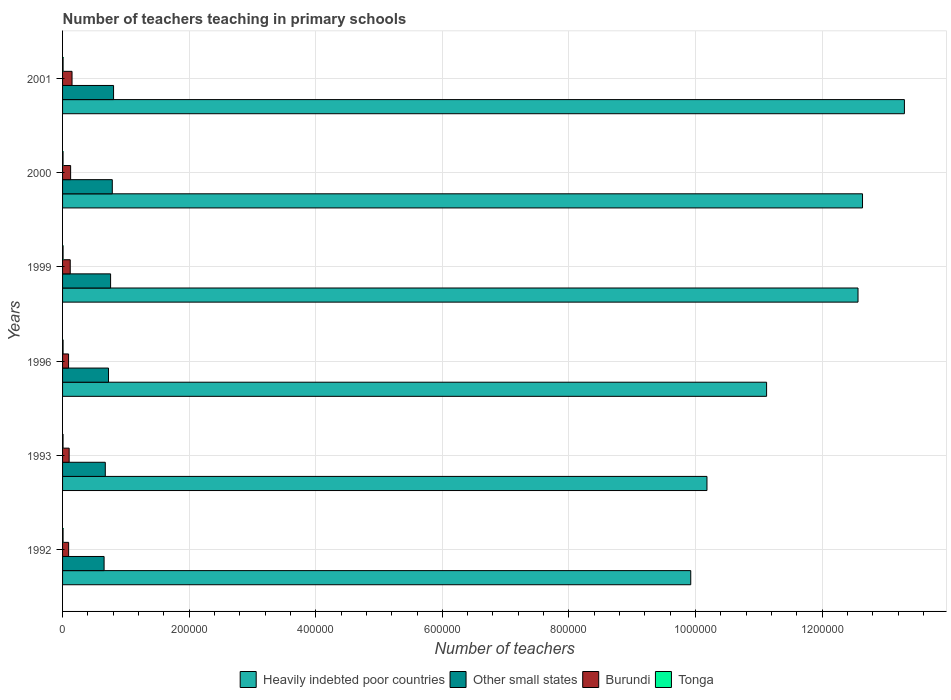How many different coloured bars are there?
Ensure brevity in your answer.  4. How many groups of bars are there?
Your answer should be very brief. 6. Are the number of bars on each tick of the Y-axis equal?
Provide a succinct answer. Yes. In how many cases, is the number of bars for a given year not equal to the number of legend labels?
Your answer should be compact. 0. What is the number of teachers teaching in primary schools in Tonga in 2000?
Provide a short and direct response. 754. Across all years, what is the maximum number of teachers teaching in primary schools in Burundi?
Your answer should be compact. 1.50e+04. Across all years, what is the minimum number of teachers teaching in primary schools in Tonga?
Give a very brief answer. 754. In which year was the number of teachers teaching in primary schools in Other small states minimum?
Offer a terse response. 1992. What is the total number of teachers teaching in primary schools in Tonga in the graph?
Your answer should be very brief. 4722. What is the difference between the number of teachers teaching in primary schools in Burundi in 1993 and that in 1996?
Your answer should be compact. 925. What is the difference between the number of teachers teaching in primary schools in Other small states in 1996 and the number of teachers teaching in primary schools in Tonga in 2001?
Offer a terse response. 7.18e+04. What is the average number of teachers teaching in primary schools in Heavily indebted poor countries per year?
Your answer should be very brief. 1.16e+06. In the year 1999, what is the difference between the number of teachers teaching in primary schools in Burundi and number of teachers teaching in primary schools in Heavily indebted poor countries?
Ensure brevity in your answer.  -1.24e+06. In how many years, is the number of teachers teaching in primary schools in Other small states greater than 1240000 ?
Ensure brevity in your answer.  0. What is the ratio of the number of teachers teaching in primary schools in Heavily indebted poor countries in 1996 to that in 1999?
Your response must be concise. 0.89. Is the number of teachers teaching in primary schools in Tonga in 1993 less than that in 1999?
Your answer should be compact. Yes. What is the difference between the highest and the second highest number of teachers teaching in primary schools in Burundi?
Provide a short and direct response. 2224. What is the difference between the highest and the lowest number of teachers teaching in primary schools in Heavily indebted poor countries?
Offer a terse response. 3.38e+05. In how many years, is the number of teachers teaching in primary schools in Other small states greater than the average number of teachers teaching in primary schools in Other small states taken over all years?
Provide a short and direct response. 3. What does the 1st bar from the top in 2001 represents?
Ensure brevity in your answer.  Tonga. What does the 2nd bar from the bottom in 1992 represents?
Provide a short and direct response. Other small states. Is it the case that in every year, the sum of the number of teachers teaching in primary schools in Heavily indebted poor countries and number of teachers teaching in primary schools in Tonga is greater than the number of teachers teaching in primary schools in Burundi?
Your answer should be very brief. Yes. Are all the bars in the graph horizontal?
Provide a succinct answer. Yes. How many years are there in the graph?
Your response must be concise. 6. What is the difference between two consecutive major ticks on the X-axis?
Make the answer very short. 2.00e+05. Are the values on the major ticks of X-axis written in scientific E-notation?
Make the answer very short. No. Does the graph contain grids?
Ensure brevity in your answer.  Yes. How many legend labels are there?
Provide a succinct answer. 4. How are the legend labels stacked?
Your answer should be compact. Horizontal. What is the title of the graph?
Give a very brief answer. Number of teachers teaching in primary schools. Does "Lesotho" appear as one of the legend labels in the graph?
Provide a succinct answer. No. What is the label or title of the X-axis?
Offer a terse response. Number of teachers. What is the Number of teachers of Heavily indebted poor countries in 1992?
Ensure brevity in your answer.  9.92e+05. What is the Number of teachers of Other small states in 1992?
Offer a terse response. 6.56e+04. What is the Number of teachers of Burundi in 1992?
Ensure brevity in your answer.  9582. What is the Number of teachers in Tonga in 1992?
Make the answer very short. 784. What is the Number of teachers in Heavily indebted poor countries in 1993?
Your answer should be very brief. 1.02e+06. What is the Number of teachers in Other small states in 1993?
Provide a succinct answer. 6.75e+04. What is the Number of teachers of Burundi in 1993?
Provide a short and direct response. 1.04e+04. What is the Number of teachers of Tonga in 1993?
Provide a short and direct response. 754. What is the Number of teachers of Heavily indebted poor countries in 1996?
Offer a terse response. 1.11e+06. What is the Number of teachers of Other small states in 1996?
Your answer should be compact. 7.26e+04. What is the Number of teachers in Burundi in 1996?
Keep it short and to the point. 9475. What is the Number of teachers in Tonga in 1996?
Offer a very short reply. 804. What is the Number of teachers in Heavily indebted poor countries in 1999?
Offer a terse response. 1.26e+06. What is the Number of teachers in Other small states in 1999?
Offer a terse response. 7.59e+04. What is the Number of teachers of Burundi in 1999?
Ensure brevity in your answer.  1.21e+04. What is the Number of teachers of Tonga in 1999?
Make the answer very short. 803. What is the Number of teachers of Heavily indebted poor countries in 2000?
Your response must be concise. 1.26e+06. What is the Number of teachers of Other small states in 2000?
Ensure brevity in your answer.  7.86e+04. What is the Number of teachers of Burundi in 2000?
Provide a short and direct response. 1.27e+04. What is the Number of teachers of Tonga in 2000?
Your answer should be very brief. 754. What is the Number of teachers in Heavily indebted poor countries in 2001?
Provide a succinct answer. 1.33e+06. What is the Number of teachers in Other small states in 2001?
Ensure brevity in your answer.  8.06e+04. What is the Number of teachers of Burundi in 2001?
Your response must be concise. 1.50e+04. What is the Number of teachers of Tonga in 2001?
Provide a succinct answer. 823. Across all years, what is the maximum Number of teachers of Heavily indebted poor countries?
Make the answer very short. 1.33e+06. Across all years, what is the maximum Number of teachers in Other small states?
Your answer should be compact. 8.06e+04. Across all years, what is the maximum Number of teachers in Burundi?
Offer a very short reply. 1.50e+04. Across all years, what is the maximum Number of teachers of Tonga?
Provide a succinct answer. 823. Across all years, what is the minimum Number of teachers of Heavily indebted poor countries?
Offer a terse response. 9.92e+05. Across all years, what is the minimum Number of teachers in Other small states?
Provide a short and direct response. 6.56e+04. Across all years, what is the minimum Number of teachers of Burundi?
Offer a very short reply. 9475. Across all years, what is the minimum Number of teachers of Tonga?
Make the answer very short. 754. What is the total Number of teachers in Heavily indebted poor countries in the graph?
Provide a short and direct response. 6.97e+06. What is the total Number of teachers of Other small states in the graph?
Your response must be concise. 4.41e+05. What is the total Number of teachers in Burundi in the graph?
Keep it short and to the point. 6.92e+04. What is the total Number of teachers in Tonga in the graph?
Provide a succinct answer. 4722. What is the difference between the Number of teachers of Heavily indebted poor countries in 1992 and that in 1993?
Ensure brevity in your answer.  -2.56e+04. What is the difference between the Number of teachers of Other small states in 1992 and that in 1993?
Make the answer very short. -1916.59. What is the difference between the Number of teachers in Burundi in 1992 and that in 1993?
Your answer should be compact. -818. What is the difference between the Number of teachers in Tonga in 1992 and that in 1993?
Provide a succinct answer. 30. What is the difference between the Number of teachers in Heavily indebted poor countries in 1992 and that in 1996?
Provide a short and direct response. -1.20e+05. What is the difference between the Number of teachers of Other small states in 1992 and that in 1996?
Your response must be concise. -6988.88. What is the difference between the Number of teachers in Burundi in 1992 and that in 1996?
Your answer should be compact. 107. What is the difference between the Number of teachers in Heavily indebted poor countries in 1992 and that in 1999?
Provide a succinct answer. -2.64e+05. What is the difference between the Number of teachers in Other small states in 1992 and that in 1999?
Offer a very short reply. -1.03e+04. What is the difference between the Number of teachers of Burundi in 1992 and that in 1999?
Offer a terse response. -2525. What is the difference between the Number of teachers in Heavily indebted poor countries in 1992 and that in 2000?
Offer a very short reply. -2.71e+05. What is the difference between the Number of teachers in Other small states in 1992 and that in 2000?
Provide a succinct answer. -1.30e+04. What is the difference between the Number of teachers in Burundi in 1992 and that in 2000?
Offer a terse response. -3149. What is the difference between the Number of teachers in Heavily indebted poor countries in 1992 and that in 2001?
Make the answer very short. -3.38e+05. What is the difference between the Number of teachers of Other small states in 1992 and that in 2001?
Offer a terse response. -1.50e+04. What is the difference between the Number of teachers of Burundi in 1992 and that in 2001?
Keep it short and to the point. -5373. What is the difference between the Number of teachers of Tonga in 1992 and that in 2001?
Offer a very short reply. -39. What is the difference between the Number of teachers of Heavily indebted poor countries in 1993 and that in 1996?
Keep it short and to the point. -9.42e+04. What is the difference between the Number of teachers in Other small states in 1993 and that in 1996?
Offer a terse response. -5072.28. What is the difference between the Number of teachers of Burundi in 1993 and that in 1996?
Ensure brevity in your answer.  925. What is the difference between the Number of teachers of Tonga in 1993 and that in 1996?
Make the answer very short. -50. What is the difference between the Number of teachers of Heavily indebted poor countries in 1993 and that in 1999?
Make the answer very short. -2.39e+05. What is the difference between the Number of teachers in Other small states in 1993 and that in 1999?
Offer a terse response. -8356.26. What is the difference between the Number of teachers in Burundi in 1993 and that in 1999?
Your response must be concise. -1707. What is the difference between the Number of teachers of Tonga in 1993 and that in 1999?
Your answer should be very brief. -49. What is the difference between the Number of teachers of Heavily indebted poor countries in 1993 and that in 2000?
Keep it short and to the point. -2.46e+05. What is the difference between the Number of teachers of Other small states in 1993 and that in 2000?
Your answer should be very brief. -1.11e+04. What is the difference between the Number of teachers of Burundi in 1993 and that in 2000?
Your answer should be very brief. -2331. What is the difference between the Number of teachers in Tonga in 1993 and that in 2000?
Provide a short and direct response. 0. What is the difference between the Number of teachers of Heavily indebted poor countries in 1993 and that in 2001?
Your answer should be compact. -3.12e+05. What is the difference between the Number of teachers in Other small states in 1993 and that in 2001?
Ensure brevity in your answer.  -1.30e+04. What is the difference between the Number of teachers of Burundi in 1993 and that in 2001?
Make the answer very short. -4555. What is the difference between the Number of teachers in Tonga in 1993 and that in 2001?
Your answer should be compact. -69. What is the difference between the Number of teachers in Heavily indebted poor countries in 1996 and that in 1999?
Make the answer very short. -1.44e+05. What is the difference between the Number of teachers in Other small states in 1996 and that in 1999?
Your response must be concise. -3283.98. What is the difference between the Number of teachers of Burundi in 1996 and that in 1999?
Offer a terse response. -2632. What is the difference between the Number of teachers of Heavily indebted poor countries in 1996 and that in 2000?
Offer a terse response. -1.52e+05. What is the difference between the Number of teachers in Other small states in 1996 and that in 2000?
Your answer should be compact. -5991.24. What is the difference between the Number of teachers of Burundi in 1996 and that in 2000?
Provide a short and direct response. -3256. What is the difference between the Number of teachers of Heavily indebted poor countries in 1996 and that in 2001?
Your answer should be very brief. -2.18e+05. What is the difference between the Number of teachers in Other small states in 1996 and that in 2001?
Give a very brief answer. -7967.1. What is the difference between the Number of teachers of Burundi in 1996 and that in 2001?
Your answer should be compact. -5480. What is the difference between the Number of teachers of Tonga in 1996 and that in 2001?
Offer a very short reply. -19. What is the difference between the Number of teachers of Heavily indebted poor countries in 1999 and that in 2000?
Offer a terse response. -7112.5. What is the difference between the Number of teachers in Other small states in 1999 and that in 2000?
Your answer should be very brief. -2707.27. What is the difference between the Number of teachers in Burundi in 1999 and that in 2000?
Provide a short and direct response. -624. What is the difference between the Number of teachers of Heavily indebted poor countries in 1999 and that in 2001?
Ensure brevity in your answer.  -7.33e+04. What is the difference between the Number of teachers of Other small states in 1999 and that in 2001?
Give a very brief answer. -4683.12. What is the difference between the Number of teachers of Burundi in 1999 and that in 2001?
Give a very brief answer. -2848. What is the difference between the Number of teachers of Heavily indebted poor countries in 2000 and that in 2001?
Give a very brief answer. -6.62e+04. What is the difference between the Number of teachers in Other small states in 2000 and that in 2001?
Keep it short and to the point. -1975.86. What is the difference between the Number of teachers of Burundi in 2000 and that in 2001?
Make the answer very short. -2224. What is the difference between the Number of teachers in Tonga in 2000 and that in 2001?
Your answer should be very brief. -69. What is the difference between the Number of teachers in Heavily indebted poor countries in 1992 and the Number of teachers in Other small states in 1993?
Keep it short and to the point. 9.25e+05. What is the difference between the Number of teachers of Heavily indebted poor countries in 1992 and the Number of teachers of Burundi in 1993?
Ensure brevity in your answer.  9.82e+05. What is the difference between the Number of teachers of Heavily indebted poor countries in 1992 and the Number of teachers of Tonga in 1993?
Provide a succinct answer. 9.92e+05. What is the difference between the Number of teachers of Other small states in 1992 and the Number of teachers of Burundi in 1993?
Ensure brevity in your answer.  5.52e+04. What is the difference between the Number of teachers in Other small states in 1992 and the Number of teachers in Tonga in 1993?
Offer a very short reply. 6.48e+04. What is the difference between the Number of teachers in Burundi in 1992 and the Number of teachers in Tonga in 1993?
Your response must be concise. 8828. What is the difference between the Number of teachers of Heavily indebted poor countries in 1992 and the Number of teachers of Other small states in 1996?
Provide a short and direct response. 9.20e+05. What is the difference between the Number of teachers in Heavily indebted poor countries in 1992 and the Number of teachers in Burundi in 1996?
Make the answer very short. 9.83e+05. What is the difference between the Number of teachers in Heavily indebted poor countries in 1992 and the Number of teachers in Tonga in 1996?
Make the answer very short. 9.92e+05. What is the difference between the Number of teachers in Other small states in 1992 and the Number of teachers in Burundi in 1996?
Make the answer very short. 5.61e+04. What is the difference between the Number of teachers in Other small states in 1992 and the Number of teachers in Tonga in 1996?
Provide a short and direct response. 6.48e+04. What is the difference between the Number of teachers in Burundi in 1992 and the Number of teachers in Tonga in 1996?
Give a very brief answer. 8778. What is the difference between the Number of teachers of Heavily indebted poor countries in 1992 and the Number of teachers of Other small states in 1999?
Give a very brief answer. 9.17e+05. What is the difference between the Number of teachers in Heavily indebted poor countries in 1992 and the Number of teachers in Burundi in 1999?
Provide a short and direct response. 9.80e+05. What is the difference between the Number of teachers in Heavily indebted poor countries in 1992 and the Number of teachers in Tonga in 1999?
Your answer should be very brief. 9.92e+05. What is the difference between the Number of teachers of Other small states in 1992 and the Number of teachers of Burundi in 1999?
Provide a short and direct response. 5.35e+04. What is the difference between the Number of teachers of Other small states in 1992 and the Number of teachers of Tonga in 1999?
Provide a short and direct response. 6.48e+04. What is the difference between the Number of teachers of Burundi in 1992 and the Number of teachers of Tonga in 1999?
Offer a terse response. 8779. What is the difference between the Number of teachers in Heavily indebted poor countries in 1992 and the Number of teachers in Other small states in 2000?
Make the answer very short. 9.14e+05. What is the difference between the Number of teachers of Heavily indebted poor countries in 1992 and the Number of teachers of Burundi in 2000?
Make the answer very short. 9.80e+05. What is the difference between the Number of teachers in Heavily indebted poor countries in 1992 and the Number of teachers in Tonga in 2000?
Your answer should be very brief. 9.92e+05. What is the difference between the Number of teachers of Other small states in 1992 and the Number of teachers of Burundi in 2000?
Make the answer very short. 5.29e+04. What is the difference between the Number of teachers in Other small states in 1992 and the Number of teachers in Tonga in 2000?
Provide a short and direct response. 6.48e+04. What is the difference between the Number of teachers in Burundi in 1992 and the Number of teachers in Tonga in 2000?
Your answer should be compact. 8828. What is the difference between the Number of teachers of Heavily indebted poor countries in 1992 and the Number of teachers of Other small states in 2001?
Make the answer very short. 9.12e+05. What is the difference between the Number of teachers of Heavily indebted poor countries in 1992 and the Number of teachers of Burundi in 2001?
Offer a very short reply. 9.78e+05. What is the difference between the Number of teachers of Heavily indebted poor countries in 1992 and the Number of teachers of Tonga in 2001?
Your response must be concise. 9.92e+05. What is the difference between the Number of teachers in Other small states in 1992 and the Number of teachers in Burundi in 2001?
Make the answer very short. 5.06e+04. What is the difference between the Number of teachers of Other small states in 1992 and the Number of teachers of Tonga in 2001?
Ensure brevity in your answer.  6.48e+04. What is the difference between the Number of teachers of Burundi in 1992 and the Number of teachers of Tonga in 2001?
Give a very brief answer. 8759. What is the difference between the Number of teachers of Heavily indebted poor countries in 1993 and the Number of teachers of Other small states in 1996?
Offer a very short reply. 9.46e+05. What is the difference between the Number of teachers in Heavily indebted poor countries in 1993 and the Number of teachers in Burundi in 1996?
Ensure brevity in your answer.  1.01e+06. What is the difference between the Number of teachers of Heavily indebted poor countries in 1993 and the Number of teachers of Tonga in 1996?
Your answer should be very brief. 1.02e+06. What is the difference between the Number of teachers in Other small states in 1993 and the Number of teachers in Burundi in 1996?
Give a very brief answer. 5.80e+04. What is the difference between the Number of teachers in Other small states in 1993 and the Number of teachers in Tonga in 1996?
Your answer should be very brief. 6.67e+04. What is the difference between the Number of teachers of Burundi in 1993 and the Number of teachers of Tonga in 1996?
Offer a very short reply. 9596. What is the difference between the Number of teachers of Heavily indebted poor countries in 1993 and the Number of teachers of Other small states in 1999?
Keep it short and to the point. 9.42e+05. What is the difference between the Number of teachers of Heavily indebted poor countries in 1993 and the Number of teachers of Burundi in 1999?
Give a very brief answer. 1.01e+06. What is the difference between the Number of teachers in Heavily indebted poor countries in 1993 and the Number of teachers in Tonga in 1999?
Ensure brevity in your answer.  1.02e+06. What is the difference between the Number of teachers in Other small states in 1993 and the Number of teachers in Burundi in 1999?
Make the answer very short. 5.54e+04. What is the difference between the Number of teachers in Other small states in 1993 and the Number of teachers in Tonga in 1999?
Provide a short and direct response. 6.67e+04. What is the difference between the Number of teachers of Burundi in 1993 and the Number of teachers of Tonga in 1999?
Your answer should be very brief. 9597. What is the difference between the Number of teachers in Heavily indebted poor countries in 1993 and the Number of teachers in Other small states in 2000?
Your answer should be very brief. 9.40e+05. What is the difference between the Number of teachers of Heavily indebted poor countries in 1993 and the Number of teachers of Burundi in 2000?
Give a very brief answer. 1.01e+06. What is the difference between the Number of teachers of Heavily indebted poor countries in 1993 and the Number of teachers of Tonga in 2000?
Make the answer very short. 1.02e+06. What is the difference between the Number of teachers in Other small states in 1993 and the Number of teachers in Burundi in 2000?
Make the answer very short. 5.48e+04. What is the difference between the Number of teachers of Other small states in 1993 and the Number of teachers of Tonga in 2000?
Offer a terse response. 6.68e+04. What is the difference between the Number of teachers in Burundi in 1993 and the Number of teachers in Tonga in 2000?
Keep it short and to the point. 9646. What is the difference between the Number of teachers in Heavily indebted poor countries in 1993 and the Number of teachers in Other small states in 2001?
Your answer should be compact. 9.38e+05. What is the difference between the Number of teachers of Heavily indebted poor countries in 1993 and the Number of teachers of Burundi in 2001?
Your answer should be very brief. 1.00e+06. What is the difference between the Number of teachers of Heavily indebted poor countries in 1993 and the Number of teachers of Tonga in 2001?
Give a very brief answer. 1.02e+06. What is the difference between the Number of teachers of Other small states in 1993 and the Number of teachers of Burundi in 2001?
Your answer should be very brief. 5.26e+04. What is the difference between the Number of teachers in Other small states in 1993 and the Number of teachers in Tonga in 2001?
Your answer should be very brief. 6.67e+04. What is the difference between the Number of teachers in Burundi in 1993 and the Number of teachers in Tonga in 2001?
Your response must be concise. 9577. What is the difference between the Number of teachers in Heavily indebted poor countries in 1996 and the Number of teachers in Other small states in 1999?
Provide a succinct answer. 1.04e+06. What is the difference between the Number of teachers in Heavily indebted poor countries in 1996 and the Number of teachers in Burundi in 1999?
Offer a very short reply. 1.10e+06. What is the difference between the Number of teachers of Heavily indebted poor countries in 1996 and the Number of teachers of Tonga in 1999?
Offer a terse response. 1.11e+06. What is the difference between the Number of teachers in Other small states in 1996 and the Number of teachers in Burundi in 1999?
Provide a short and direct response. 6.05e+04. What is the difference between the Number of teachers of Other small states in 1996 and the Number of teachers of Tonga in 1999?
Ensure brevity in your answer.  7.18e+04. What is the difference between the Number of teachers of Burundi in 1996 and the Number of teachers of Tonga in 1999?
Your response must be concise. 8672. What is the difference between the Number of teachers of Heavily indebted poor countries in 1996 and the Number of teachers of Other small states in 2000?
Make the answer very short. 1.03e+06. What is the difference between the Number of teachers of Heavily indebted poor countries in 1996 and the Number of teachers of Burundi in 2000?
Your answer should be very brief. 1.10e+06. What is the difference between the Number of teachers in Heavily indebted poor countries in 1996 and the Number of teachers in Tonga in 2000?
Provide a succinct answer. 1.11e+06. What is the difference between the Number of teachers in Other small states in 1996 and the Number of teachers in Burundi in 2000?
Your answer should be compact. 5.99e+04. What is the difference between the Number of teachers of Other small states in 1996 and the Number of teachers of Tonga in 2000?
Make the answer very short. 7.18e+04. What is the difference between the Number of teachers in Burundi in 1996 and the Number of teachers in Tonga in 2000?
Keep it short and to the point. 8721. What is the difference between the Number of teachers in Heavily indebted poor countries in 1996 and the Number of teachers in Other small states in 2001?
Your answer should be compact. 1.03e+06. What is the difference between the Number of teachers of Heavily indebted poor countries in 1996 and the Number of teachers of Burundi in 2001?
Provide a succinct answer. 1.10e+06. What is the difference between the Number of teachers in Heavily indebted poor countries in 1996 and the Number of teachers in Tonga in 2001?
Your answer should be very brief. 1.11e+06. What is the difference between the Number of teachers in Other small states in 1996 and the Number of teachers in Burundi in 2001?
Give a very brief answer. 5.76e+04. What is the difference between the Number of teachers in Other small states in 1996 and the Number of teachers in Tonga in 2001?
Ensure brevity in your answer.  7.18e+04. What is the difference between the Number of teachers in Burundi in 1996 and the Number of teachers in Tonga in 2001?
Provide a short and direct response. 8652. What is the difference between the Number of teachers of Heavily indebted poor countries in 1999 and the Number of teachers of Other small states in 2000?
Make the answer very short. 1.18e+06. What is the difference between the Number of teachers in Heavily indebted poor countries in 1999 and the Number of teachers in Burundi in 2000?
Your answer should be very brief. 1.24e+06. What is the difference between the Number of teachers of Heavily indebted poor countries in 1999 and the Number of teachers of Tonga in 2000?
Provide a short and direct response. 1.26e+06. What is the difference between the Number of teachers of Other small states in 1999 and the Number of teachers of Burundi in 2000?
Offer a terse response. 6.31e+04. What is the difference between the Number of teachers in Other small states in 1999 and the Number of teachers in Tonga in 2000?
Keep it short and to the point. 7.51e+04. What is the difference between the Number of teachers of Burundi in 1999 and the Number of teachers of Tonga in 2000?
Your response must be concise. 1.14e+04. What is the difference between the Number of teachers in Heavily indebted poor countries in 1999 and the Number of teachers in Other small states in 2001?
Provide a succinct answer. 1.18e+06. What is the difference between the Number of teachers in Heavily indebted poor countries in 1999 and the Number of teachers in Burundi in 2001?
Make the answer very short. 1.24e+06. What is the difference between the Number of teachers of Heavily indebted poor countries in 1999 and the Number of teachers of Tonga in 2001?
Offer a terse response. 1.26e+06. What is the difference between the Number of teachers in Other small states in 1999 and the Number of teachers in Burundi in 2001?
Offer a terse response. 6.09e+04. What is the difference between the Number of teachers of Other small states in 1999 and the Number of teachers of Tonga in 2001?
Give a very brief answer. 7.51e+04. What is the difference between the Number of teachers in Burundi in 1999 and the Number of teachers in Tonga in 2001?
Provide a succinct answer. 1.13e+04. What is the difference between the Number of teachers in Heavily indebted poor countries in 2000 and the Number of teachers in Other small states in 2001?
Give a very brief answer. 1.18e+06. What is the difference between the Number of teachers in Heavily indebted poor countries in 2000 and the Number of teachers in Burundi in 2001?
Your response must be concise. 1.25e+06. What is the difference between the Number of teachers of Heavily indebted poor countries in 2000 and the Number of teachers of Tonga in 2001?
Offer a terse response. 1.26e+06. What is the difference between the Number of teachers in Other small states in 2000 and the Number of teachers in Burundi in 2001?
Provide a short and direct response. 6.36e+04. What is the difference between the Number of teachers in Other small states in 2000 and the Number of teachers in Tonga in 2001?
Give a very brief answer. 7.78e+04. What is the difference between the Number of teachers in Burundi in 2000 and the Number of teachers in Tonga in 2001?
Offer a terse response. 1.19e+04. What is the average Number of teachers in Heavily indebted poor countries per year?
Provide a succinct answer. 1.16e+06. What is the average Number of teachers in Other small states per year?
Ensure brevity in your answer.  7.35e+04. What is the average Number of teachers in Burundi per year?
Keep it short and to the point. 1.15e+04. What is the average Number of teachers of Tonga per year?
Your answer should be compact. 787. In the year 1992, what is the difference between the Number of teachers of Heavily indebted poor countries and Number of teachers of Other small states?
Offer a very short reply. 9.27e+05. In the year 1992, what is the difference between the Number of teachers of Heavily indebted poor countries and Number of teachers of Burundi?
Your answer should be very brief. 9.83e+05. In the year 1992, what is the difference between the Number of teachers in Heavily indebted poor countries and Number of teachers in Tonga?
Offer a very short reply. 9.92e+05. In the year 1992, what is the difference between the Number of teachers in Other small states and Number of teachers in Burundi?
Make the answer very short. 5.60e+04. In the year 1992, what is the difference between the Number of teachers in Other small states and Number of teachers in Tonga?
Offer a terse response. 6.48e+04. In the year 1992, what is the difference between the Number of teachers of Burundi and Number of teachers of Tonga?
Your answer should be very brief. 8798. In the year 1993, what is the difference between the Number of teachers in Heavily indebted poor countries and Number of teachers in Other small states?
Keep it short and to the point. 9.51e+05. In the year 1993, what is the difference between the Number of teachers of Heavily indebted poor countries and Number of teachers of Burundi?
Your response must be concise. 1.01e+06. In the year 1993, what is the difference between the Number of teachers of Heavily indebted poor countries and Number of teachers of Tonga?
Give a very brief answer. 1.02e+06. In the year 1993, what is the difference between the Number of teachers of Other small states and Number of teachers of Burundi?
Ensure brevity in your answer.  5.71e+04. In the year 1993, what is the difference between the Number of teachers of Other small states and Number of teachers of Tonga?
Provide a short and direct response. 6.68e+04. In the year 1993, what is the difference between the Number of teachers in Burundi and Number of teachers in Tonga?
Make the answer very short. 9646. In the year 1996, what is the difference between the Number of teachers of Heavily indebted poor countries and Number of teachers of Other small states?
Give a very brief answer. 1.04e+06. In the year 1996, what is the difference between the Number of teachers in Heavily indebted poor countries and Number of teachers in Burundi?
Give a very brief answer. 1.10e+06. In the year 1996, what is the difference between the Number of teachers of Heavily indebted poor countries and Number of teachers of Tonga?
Your answer should be compact. 1.11e+06. In the year 1996, what is the difference between the Number of teachers of Other small states and Number of teachers of Burundi?
Your answer should be very brief. 6.31e+04. In the year 1996, what is the difference between the Number of teachers in Other small states and Number of teachers in Tonga?
Provide a short and direct response. 7.18e+04. In the year 1996, what is the difference between the Number of teachers of Burundi and Number of teachers of Tonga?
Keep it short and to the point. 8671. In the year 1999, what is the difference between the Number of teachers of Heavily indebted poor countries and Number of teachers of Other small states?
Your answer should be very brief. 1.18e+06. In the year 1999, what is the difference between the Number of teachers of Heavily indebted poor countries and Number of teachers of Burundi?
Make the answer very short. 1.24e+06. In the year 1999, what is the difference between the Number of teachers in Heavily indebted poor countries and Number of teachers in Tonga?
Your answer should be very brief. 1.26e+06. In the year 1999, what is the difference between the Number of teachers of Other small states and Number of teachers of Burundi?
Offer a terse response. 6.38e+04. In the year 1999, what is the difference between the Number of teachers of Other small states and Number of teachers of Tonga?
Keep it short and to the point. 7.51e+04. In the year 1999, what is the difference between the Number of teachers in Burundi and Number of teachers in Tonga?
Make the answer very short. 1.13e+04. In the year 2000, what is the difference between the Number of teachers in Heavily indebted poor countries and Number of teachers in Other small states?
Your answer should be compact. 1.19e+06. In the year 2000, what is the difference between the Number of teachers of Heavily indebted poor countries and Number of teachers of Burundi?
Your response must be concise. 1.25e+06. In the year 2000, what is the difference between the Number of teachers in Heavily indebted poor countries and Number of teachers in Tonga?
Provide a short and direct response. 1.26e+06. In the year 2000, what is the difference between the Number of teachers of Other small states and Number of teachers of Burundi?
Your answer should be very brief. 6.59e+04. In the year 2000, what is the difference between the Number of teachers in Other small states and Number of teachers in Tonga?
Make the answer very short. 7.78e+04. In the year 2000, what is the difference between the Number of teachers of Burundi and Number of teachers of Tonga?
Your answer should be compact. 1.20e+04. In the year 2001, what is the difference between the Number of teachers in Heavily indebted poor countries and Number of teachers in Other small states?
Offer a terse response. 1.25e+06. In the year 2001, what is the difference between the Number of teachers of Heavily indebted poor countries and Number of teachers of Burundi?
Provide a succinct answer. 1.32e+06. In the year 2001, what is the difference between the Number of teachers in Heavily indebted poor countries and Number of teachers in Tonga?
Keep it short and to the point. 1.33e+06. In the year 2001, what is the difference between the Number of teachers in Other small states and Number of teachers in Burundi?
Make the answer very short. 6.56e+04. In the year 2001, what is the difference between the Number of teachers of Other small states and Number of teachers of Tonga?
Your response must be concise. 7.97e+04. In the year 2001, what is the difference between the Number of teachers of Burundi and Number of teachers of Tonga?
Offer a very short reply. 1.41e+04. What is the ratio of the Number of teachers in Heavily indebted poor countries in 1992 to that in 1993?
Provide a succinct answer. 0.97. What is the ratio of the Number of teachers in Other small states in 1992 to that in 1993?
Offer a very short reply. 0.97. What is the ratio of the Number of teachers of Burundi in 1992 to that in 1993?
Your response must be concise. 0.92. What is the ratio of the Number of teachers in Tonga in 1992 to that in 1993?
Keep it short and to the point. 1.04. What is the ratio of the Number of teachers of Heavily indebted poor countries in 1992 to that in 1996?
Offer a very short reply. 0.89. What is the ratio of the Number of teachers in Other small states in 1992 to that in 1996?
Give a very brief answer. 0.9. What is the ratio of the Number of teachers in Burundi in 1992 to that in 1996?
Provide a short and direct response. 1.01. What is the ratio of the Number of teachers in Tonga in 1992 to that in 1996?
Offer a very short reply. 0.98. What is the ratio of the Number of teachers of Heavily indebted poor countries in 1992 to that in 1999?
Your answer should be compact. 0.79. What is the ratio of the Number of teachers of Other small states in 1992 to that in 1999?
Make the answer very short. 0.86. What is the ratio of the Number of teachers in Burundi in 1992 to that in 1999?
Provide a short and direct response. 0.79. What is the ratio of the Number of teachers in Tonga in 1992 to that in 1999?
Keep it short and to the point. 0.98. What is the ratio of the Number of teachers in Heavily indebted poor countries in 1992 to that in 2000?
Keep it short and to the point. 0.79. What is the ratio of the Number of teachers of Other small states in 1992 to that in 2000?
Offer a terse response. 0.83. What is the ratio of the Number of teachers in Burundi in 1992 to that in 2000?
Your response must be concise. 0.75. What is the ratio of the Number of teachers in Tonga in 1992 to that in 2000?
Your response must be concise. 1.04. What is the ratio of the Number of teachers in Heavily indebted poor countries in 1992 to that in 2001?
Your response must be concise. 0.75. What is the ratio of the Number of teachers in Other small states in 1992 to that in 2001?
Offer a very short reply. 0.81. What is the ratio of the Number of teachers in Burundi in 1992 to that in 2001?
Ensure brevity in your answer.  0.64. What is the ratio of the Number of teachers of Tonga in 1992 to that in 2001?
Your answer should be very brief. 0.95. What is the ratio of the Number of teachers of Heavily indebted poor countries in 1993 to that in 1996?
Make the answer very short. 0.92. What is the ratio of the Number of teachers in Other small states in 1993 to that in 1996?
Give a very brief answer. 0.93. What is the ratio of the Number of teachers of Burundi in 1993 to that in 1996?
Your answer should be compact. 1.1. What is the ratio of the Number of teachers in Tonga in 1993 to that in 1996?
Provide a succinct answer. 0.94. What is the ratio of the Number of teachers of Heavily indebted poor countries in 1993 to that in 1999?
Keep it short and to the point. 0.81. What is the ratio of the Number of teachers in Other small states in 1993 to that in 1999?
Offer a very short reply. 0.89. What is the ratio of the Number of teachers of Burundi in 1993 to that in 1999?
Make the answer very short. 0.86. What is the ratio of the Number of teachers of Tonga in 1993 to that in 1999?
Provide a succinct answer. 0.94. What is the ratio of the Number of teachers of Heavily indebted poor countries in 1993 to that in 2000?
Your answer should be very brief. 0.81. What is the ratio of the Number of teachers in Other small states in 1993 to that in 2000?
Provide a succinct answer. 0.86. What is the ratio of the Number of teachers in Burundi in 1993 to that in 2000?
Your response must be concise. 0.82. What is the ratio of the Number of teachers in Tonga in 1993 to that in 2000?
Offer a very short reply. 1. What is the ratio of the Number of teachers in Heavily indebted poor countries in 1993 to that in 2001?
Your answer should be very brief. 0.77. What is the ratio of the Number of teachers in Other small states in 1993 to that in 2001?
Your answer should be very brief. 0.84. What is the ratio of the Number of teachers in Burundi in 1993 to that in 2001?
Offer a terse response. 0.7. What is the ratio of the Number of teachers of Tonga in 1993 to that in 2001?
Keep it short and to the point. 0.92. What is the ratio of the Number of teachers of Heavily indebted poor countries in 1996 to that in 1999?
Your answer should be very brief. 0.89. What is the ratio of the Number of teachers of Other small states in 1996 to that in 1999?
Provide a succinct answer. 0.96. What is the ratio of the Number of teachers in Burundi in 1996 to that in 1999?
Make the answer very short. 0.78. What is the ratio of the Number of teachers in Tonga in 1996 to that in 1999?
Your answer should be very brief. 1. What is the ratio of the Number of teachers of Heavily indebted poor countries in 1996 to that in 2000?
Your answer should be very brief. 0.88. What is the ratio of the Number of teachers of Other small states in 1996 to that in 2000?
Offer a very short reply. 0.92. What is the ratio of the Number of teachers of Burundi in 1996 to that in 2000?
Make the answer very short. 0.74. What is the ratio of the Number of teachers of Tonga in 1996 to that in 2000?
Your response must be concise. 1.07. What is the ratio of the Number of teachers of Heavily indebted poor countries in 1996 to that in 2001?
Offer a terse response. 0.84. What is the ratio of the Number of teachers in Other small states in 1996 to that in 2001?
Your answer should be very brief. 0.9. What is the ratio of the Number of teachers of Burundi in 1996 to that in 2001?
Make the answer very short. 0.63. What is the ratio of the Number of teachers of Tonga in 1996 to that in 2001?
Ensure brevity in your answer.  0.98. What is the ratio of the Number of teachers in Other small states in 1999 to that in 2000?
Ensure brevity in your answer.  0.97. What is the ratio of the Number of teachers of Burundi in 1999 to that in 2000?
Your answer should be very brief. 0.95. What is the ratio of the Number of teachers in Tonga in 1999 to that in 2000?
Make the answer very short. 1.06. What is the ratio of the Number of teachers of Heavily indebted poor countries in 1999 to that in 2001?
Your answer should be compact. 0.94. What is the ratio of the Number of teachers in Other small states in 1999 to that in 2001?
Make the answer very short. 0.94. What is the ratio of the Number of teachers in Burundi in 1999 to that in 2001?
Give a very brief answer. 0.81. What is the ratio of the Number of teachers in Tonga in 1999 to that in 2001?
Give a very brief answer. 0.98. What is the ratio of the Number of teachers in Heavily indebted poor countries in 2000 to that in 2001?
Offer a very short reply. 0.95. What is the ratio of the Number of teachers of Other small states in 2000 to that in 2001?
Offer a terse response. 0.98. What is the ratio of the Number of teachers in Burundi in 2000 to that in 2001?
Your response must be concise. 0.85. What is the ratio of the Number of teachers in Tonga in 2000 to that in 2001?
Offer a very short reply. 0.92. What is the difference between the highest and the second highest Number of teachers of Heavily indebted poor countries?
Your answer should be very brief. 6.62e+04. What is the difference between the highest and the second highest Number of teachers of Other small states?
Your answer should be compact. 1975.86. What is the difference between the highest and the second highest Number of teachers in Burundi?
Keep it short and to the point. 2224. What is the difference between the highest and the lowest Number of teachers of Heavily indebted poor countries?
Your answer should be compact. 3.38e+05. What is the difference between the highest and the lowest Number of teachers in Other small states?
Your answer should be very brief. 1.50e+04. What is the difference between the highest and the lowest Number of teachers of Burundi?
Keep it short and to the point. 5480. What is the difference between the highest and the lowest Number of teachers of Tonga?
Ensure brevity in your answer.  69. 